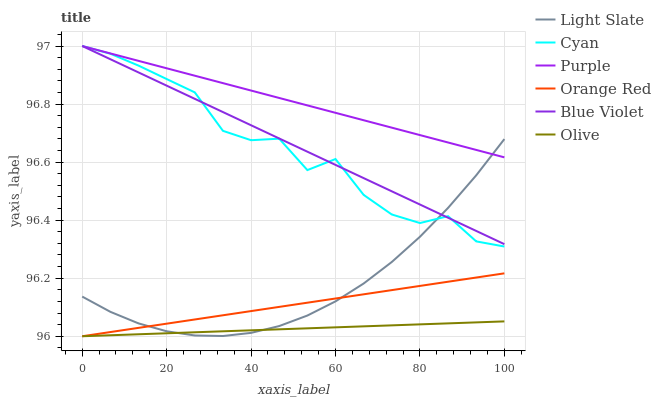Does Olive have the minimum area under the curve?
Answer yes or no. Yes. Does Purple have the maximum area under the curve?
Answer yes or no. Yes. Does Purple have the minimum area under the curve?
Answer yes or no. No. Does Olive have the maximum area under the curve?
Answer yes or no. No. Is Olive the smoothest?
Answer yes or no. Yes. Is Cyan the roughest?
Answer yes or no. Yes. Is Purple the smoothest?
Answer yes or no. No. Is Purple the roughest?
Answer yes or no. No. Does Olive have the lowest value?
Answer yes or no. Yes. Does Purple have the lowest value?
Answer yes or no. No. Does Blue Violet have the highest value?
Answer yes or no. Yes. Does Olive have the highest value?
Answer yes or no. No. Is Olive less than Cyan?
Answer yes or no. Yes. Is Purple greater than Orange Red?
Answer yes or no. Yes. Does Cyan intersect Light Slate?
Answer yes or no. Yes. Is Cyan less than Light Slate?
Answer yes or no. No. Is Cyan greater than Light Slate?
Answer yes or no. No. Does Olive intersect Cyan?
Answer yes or no. No. 